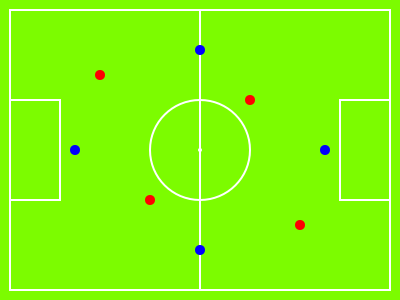As a coach focused on team image and performance, analyze the formation depicted in the diagram. How would you describe this setup, and what potential advantages or disadvantages does it present for both offensive and defensive play? To analyze this formation, let's break it down step-by-step:

1. Player positions:
   - 4 red players (likely attackers)
   - 4 blue players (likely defenders)

2. Formation structure:
   - The blue players form a diamond shape
   - The red players are spread out in a more fluid formation

3. Defensive analysis:
   - The diamond defense provides good coverage of the field
   - It allows for quick transitions between defense and offense
   - However, it may leave the wings vulnerable to attacks

4. Offensive analysis:
   - The spread of red players creates multiple attacking options
   - It allows for fluid movement and unpredictable play
   - But it may lack a dedicated striker or target man

5. Advantages:
   - Flexibility in both attack and defense
   - Good field coverage
   - Potential for quick counterattacks

6. Disadvantages:
   - Possible vulnerability on the wings
   - Lack of a clear focal point in attack
   - Requires high fitness levels and tactical understanding from players

7. Overall assessment:
   This formation appears to be a 4-4-2 diamond or 4-1-2-1-2, which emphasizes midfield control and fluid attacking play. It suits a team with technically skilled players who can adapt to multiple roles.
Answer: 4-4-2 diamond formation: balanced, flexible, emphasizes midfield control and fluid attack, but potentially vulnerable on wings. 